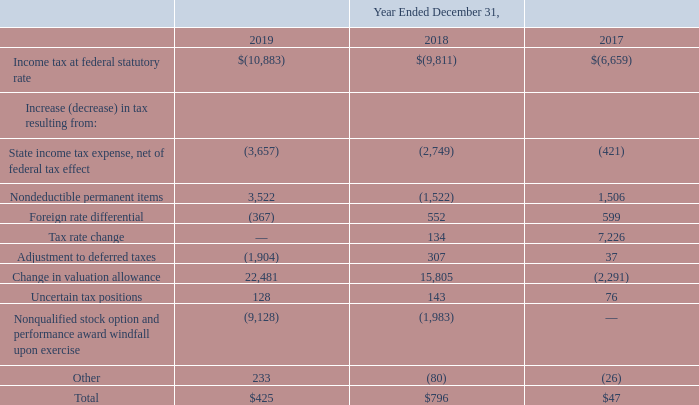For purposes of reconciling the Company’s provision for income taxes at the statutory rate and the Company’s provision (benefit) for income taxes at the effective tax rate, a notional 26% tax rate was applied as follows (in thousands):
The difference between the statutory federal income tax rate and the Company’s effective tax rate in 2019, 2018 and 2017 is primarily attributable to the effect of state income taxes, difference between the U.S. and foreign tax rates, deferred tax state rate adjustment, share-based compensation, true up of deferred taxes, other non-deductible permanent items, and change in valuation allowance. In addition, the Company’s foreign subsidiaries are subject to varied applicable statutory income tax rates for the periods presented.
What was the notional tax rate? 26%. What was the Income tax at federal statutory rate in 2019, 2018 and 2017?
Answer scale should be: thousand. $(10,883), $(9,811), $(6,659). What was the reason for difference between he statutory federal income tax rate and the Company’s effective tax rate in 2019, 2018 and 2017? The effect of state income taxes, difference between the u.s. and foreign tax rates, deferred tax state rate adjustment, share-based compensation, true up of deferred taxes, other non-deductible permanent items, and change in valuation allowance. In which year was State income tax expense, net of federal tax effect less than (1,000) thousands? Locate and analyze state income tax expense, net of federal tax effect in row 5
answer: 2017. What is the average Nondeductible permanent items from 2017-2019?
Answer scale should be: thousand. (3,522 - 1,522 + 1,506) / 3
Answer: 1168.67. What was the average Tax rate change from 2017-2019?
Answer scale should be: thousand. (0 + 134 + 7,226) / 3
Answer: 2453.33. 